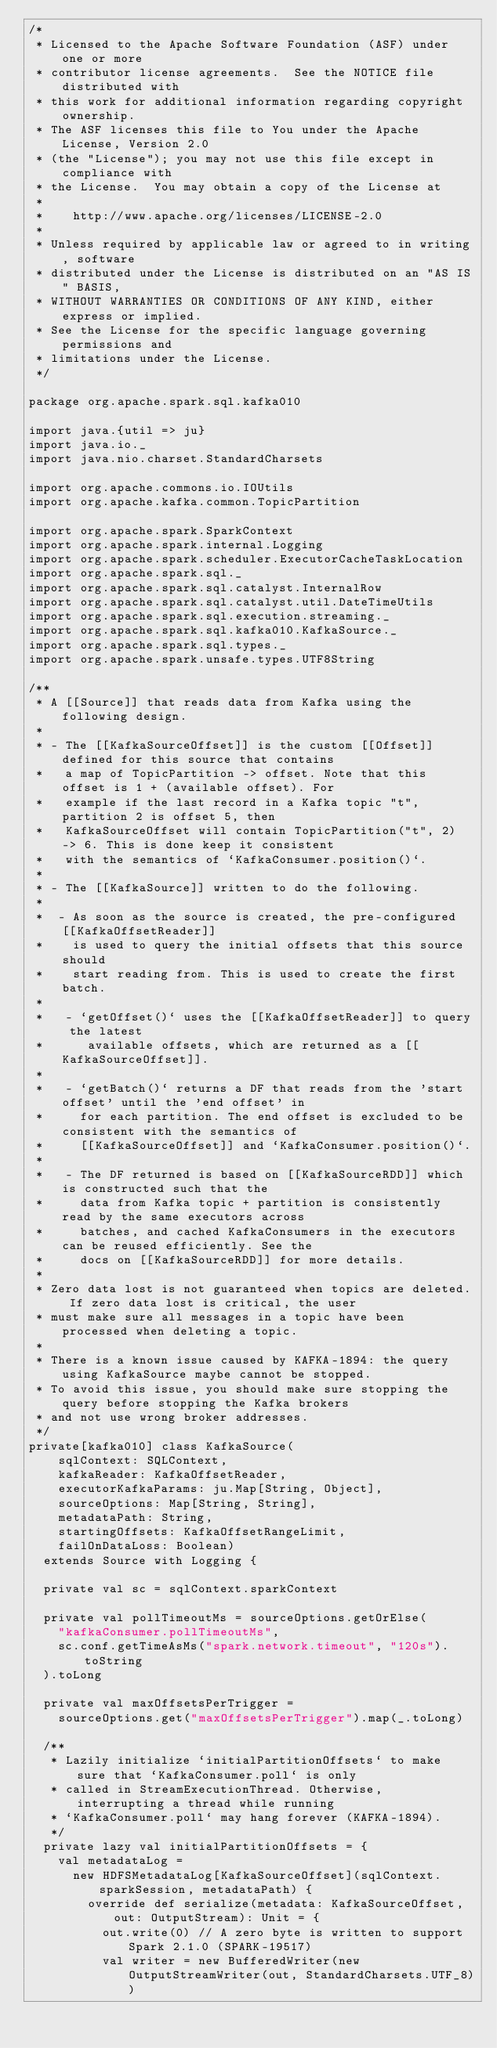<code> <loc_0><loc_0><loc_500><loc_500><_Scala_>/*
 * Licensed to the Apache Software Foundation (ASF) under one or more
 * contributor license agreements.  See the NOTICE file distributed with
 * this work for additional information regarding copyright ownership.
 * The ASF licenses this file to You under the Apache License, Version 2.0
 * (the "License"); you may not use this file except in compliance with
 * the License.  You may obtain a copy of the License at
 *
 *    http://www.apache.org/licenses/LICENSE-2.0
 *
 * Unless required by applicable law or agreed to in writing, software
 * distributed under the License is distributed on an "AS IS" BASIS,
 * WITHOUT WARRANTIES OR CONDITIONS OF ANY KIND, either express or implied.
 * See the License for the specific language governing permissions and
 * limitations under the License.
 */

package org.apache.spark.sql.kafka010

import java.{util => ju}
import java.io._
import java.nio.charset.StandardCharsets

import org.apache.commons.io.IOUtils
import org.apache.kafka.common.TopicPartition

import org.apache.spark.SparkContext
import org.apache.spark.internal.Logging
import org.apache.spark.scheduler.ExecutorCacheTaskLocation
import org.apache.spark.sql._
import org.apache.spark.sql.catalyst.InternalRow
import org.apache.spark.sql.catalyst.util.DateTimeUtils
import org.apache.spark.sql.execution.streaming._
import org.apache.spark.sql.kafka010.KafkaSource._
import org.apache.spark.sql.types._
import org.apache.spark.unsafe.types.UTF8String

/**
 * A [[Source]] that reads data from Kafka using the following design.
 *
 * - The [[KafkaSourceOffset]] is the custom [[Offset]] defined for this source that contains
 *   a map of TopicPartition -> offset. Note that this offset is 1 + (available offset). For
 *   example if the last record in a Kafka topic "t", partition 2 is offset 5, then
 *   KafkaSourceOffset will contain TopicPartition("t", 2) -> 6. This is done keep it consistent
 *   with the semantics of `KafkaConsumer.position()`.
 *
 * - The [[KafkaSource]] written to do the following.
 *
 *  - As soon as the source is created, the pre-configured [[KafkaOffsetReader]]
 *    is used to query the initial offsets that this source should
 *    start reading from. This is used to create the first batch.
 *
 *   - `getOffset()` uses the [[KafkaOffsetReader]] to query the latest
 *      available offsets, which are returned as a [[KafkaSourceOffset]].
 *
 *   - `getBatch()` returns a DF that reads from the 'start offset' until the 'end offset' in
 *     for each partition. The end offset is excluded to be consistent with the semantics of
 *     [[KafkaSourceOffset]] and `KafkaConsumer.position()`.
 *
 *   - The DF returned is based on [[KafkaSourceRDD]] which is constructed such that the
 *     data from Kafka topic + partition is consistently read by the same executors across
 *     batches, and cached KafkaConsumers in the executors can be reused efficiently. See the
 *     docs on [[KafkaSourceRDD]] for more details.
 *
 * Zero data lost is not guaranteed when topics are deleted. If zero data lost is critical, the user
 * must make sure all messages in a topic have been processed when deleting a topic.
 *
 * There is a known issue caused by KAFKA-1894: the query using KafkaSource maybe cannot be stopped.
 * To avoid this issue, you should make sure stopping the query before stopping the Kafka brokers
 * and not use wrong broker addresses.
 */
private[kafka010] class KafkaSource(
    sqlContext: SQLContext,
    kafkaReader: KafkaOffsetReader,
    executorKafkaParams: ju.Map[String, Object],
    sourceOptions: Map[String, String],
    metadataPath: String,
    startingOffsets: KafkaOffsetRangeLimit,
    failOnDataLoss: Boolean)
  extends Source with Logging {

  private val sc = sqlContext.sparkContext

  private val pollTimeoutMs = sourceOptions.getOrElse(
    "kafkaConsumer.pollTimeoutMs",
    sc.conf.getTimeAsMs("spark.network.timeout", "120s").toString
  ).toLong

  private val maxOffsetsPerTrigger =
    sourceOptions.get("maxOffsetsPerTrigger").map(_.toLong)

  /**
   * Lazily initialize `initialPartitionOffsets` to make sure that `KafkaConsumer.poll` is only
   * called in StreamExecutionThread. Otherwise, interrupting a thread while running
   * `KafkaConsumer.poll` may hang forever (KAFKA-1894).
   */
  private lazy val initialPartitionOffsets = {
    val metadataLog =
      new HDFSMetadataLog[KafkaSourceOffset](sqlContext.sparkSession, metadataPath) {
        override def serialize(metadata: KafkaSourceOffset, out: OutputStream): Unit = {
          out.write(0) // A zero byte is written to support Spark 2.1.0 (SPARK-19517)
          val writer = new BufferedWriter(new OutputStreamWriter(out, StandardCharsets.UTF_8))</code> 